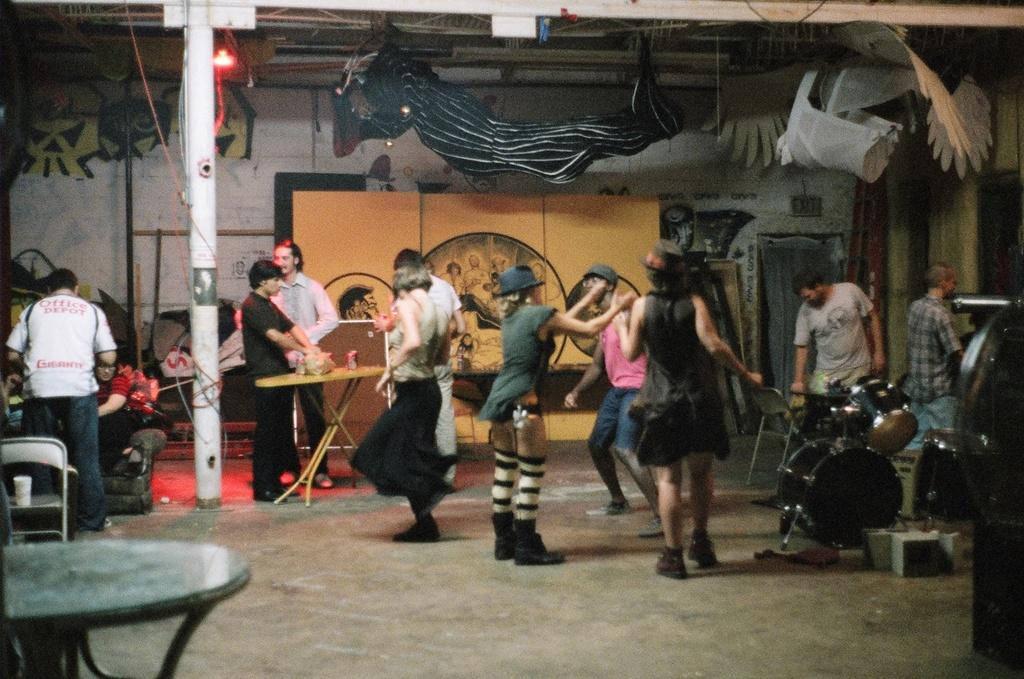What is happening in the image? There is a group of people in the image, and they are dancing. What can be seen in the background of the image? There are paintings on the wall in the background of the image. What type of oven is being used by the people in the image? There is no oven present in the image; the people are dancing. 